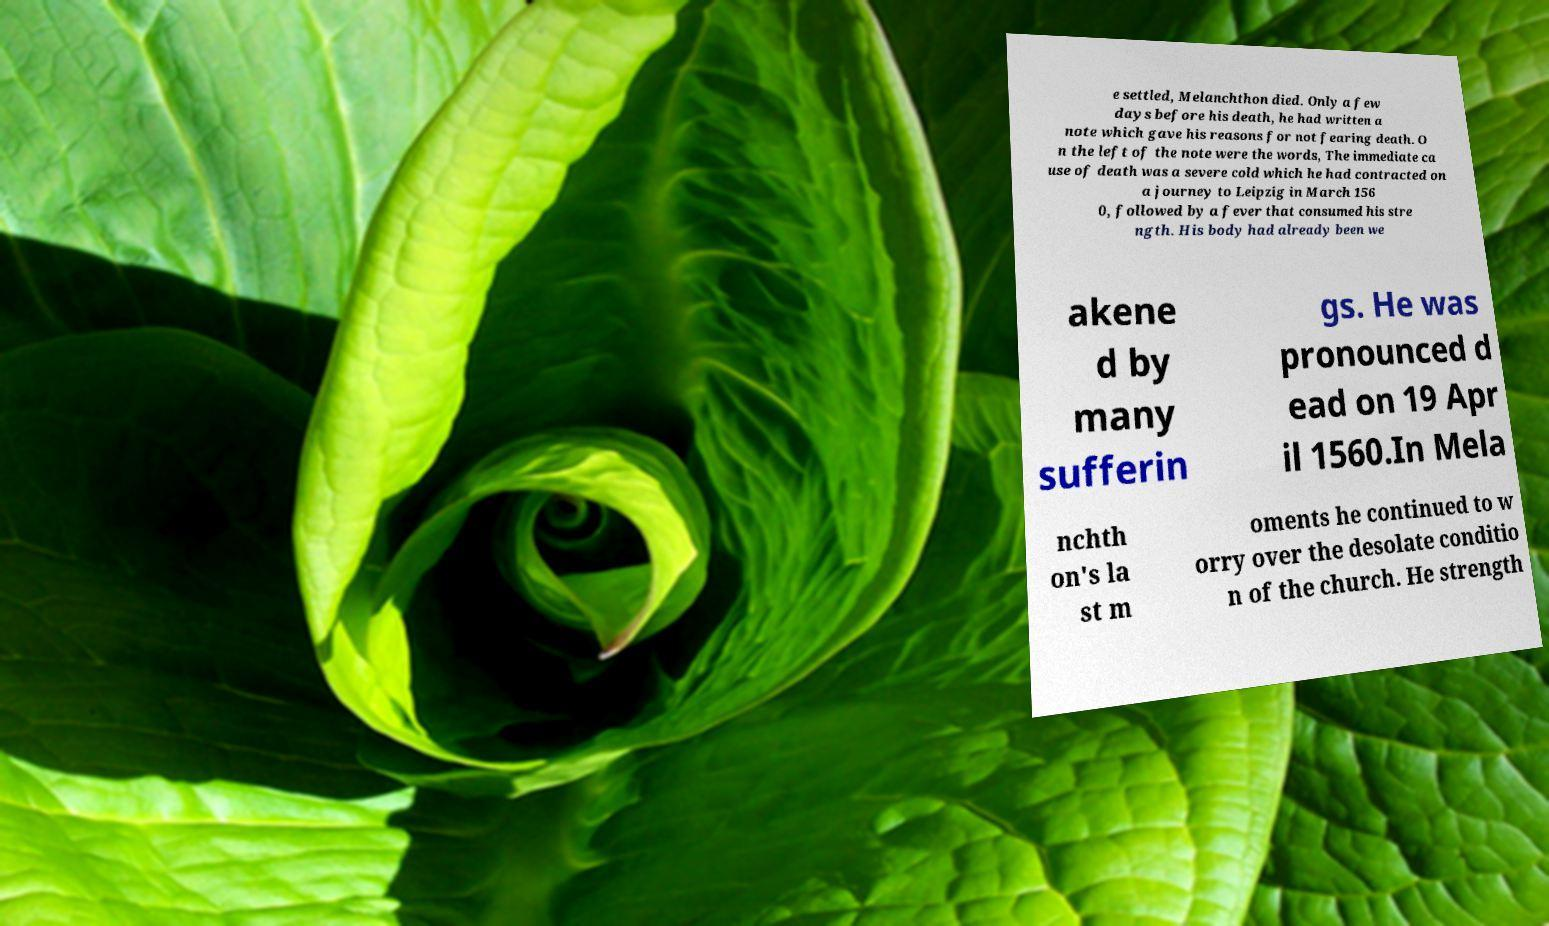For documentation purposes, I need the text within this image transcribed. Could you provide that? e settled, Melanchthon died. Only a few days before his death, he had written a note which gave his reasons for not fearing death. O n the left of the note were the words, The immediate ca use of death was a severe cold which he had contracted on a journey to Leipzig in March 156 0, followed by a fever that consumed his stre ngth. His body had already been we akene d by many sufferin gs. He was pronounced d ead on 19 Apr il 1560.In Mela nchth on's la st m oments he continued to w orry over the desolate conditio n of the church. He strength 